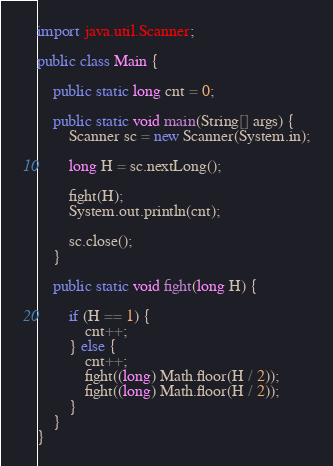<code> <loc_0><loc_0><loc_500><loc_500><_Java_>import java.util.Scanner;

public class Main {

	public static long cnt = 0;

	public static void main(String[] args) {
		Scanner sc = new Scanner(System.in);

		long H = sc.nextLong();

		fight(H);
		System.out.println(cnt);

		sc.close();
	}

	public static void fight(long H) {

		if (H == 1) {
			cnt++;
		} else {
			cnt++;
			fight((long) Math.floor(H / 2));
			fight((long) Math.floor(H / 2));
		}
	}
}
</code> 